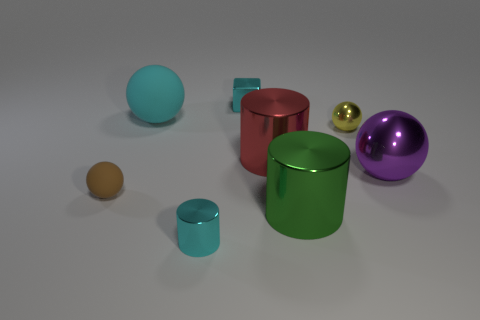There is a large purple thing that is the same material as the block; what shape is it?
Make the answer very short. Sphere. Is there anything else that has the same color as the small matte sphere?
Provide a short and direct response. No. There is a sphere right of the small ball that is behind the big red cylinder; what color is it?
Ensure brevity in your answer.  Purple. What number of tiny things are brown balls or rubber balls?
Provide a short and direct response. 1. There is a small brown object that is the same shape as the large cyan object; what is it made of?
Make the answer very short. Rubber. The tiny rubber thing has what color?
Ensure brevity in your answer.  Brown. Does the tiny cube have the same color as the tiny cylinder?
Your response must be concise. Yes. There is a cylinder in front of the big green metal object; what number of small shiny things are on the right side of it?
Provide a short and direct response. 2. How big is the metal object that is behind the red thing and on the right side of the big green shiny object?
Your answer should be compact. Small. What is the material of the large ball on the left side of the purple sphere?
Your answer should be very brief. Rubber. 